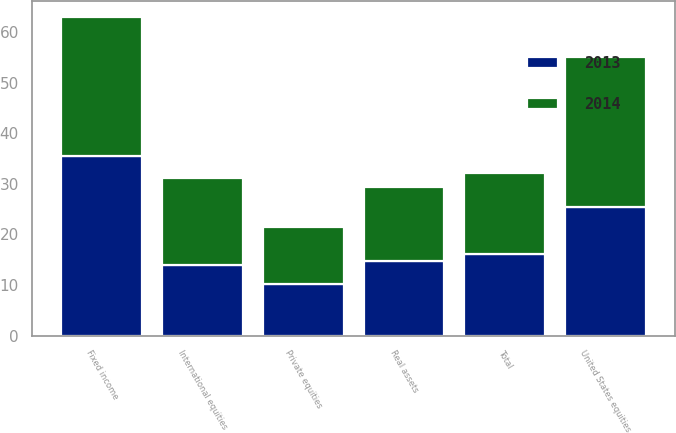Convert chart. <chart><loc_0><loc_0><loc_500><loc_500><stacked_bar_chart><ecel><fcel>United States equities<fcel>International equities<fcel>Private equities<fcel>Fixed income<fcel>Real assets<fcel>Total<nl><fcel>2013<fcel>25.5<fcel>13.9<fcel>10.3<fcel>35.5<fcel>14.8<fcel>16.05<nl><fcel>2014<fcel>29.5<fcel>17.3<fcel>11.2<fcel>27.5<fcel>14.5<fcel>16.05<nl></chart> 